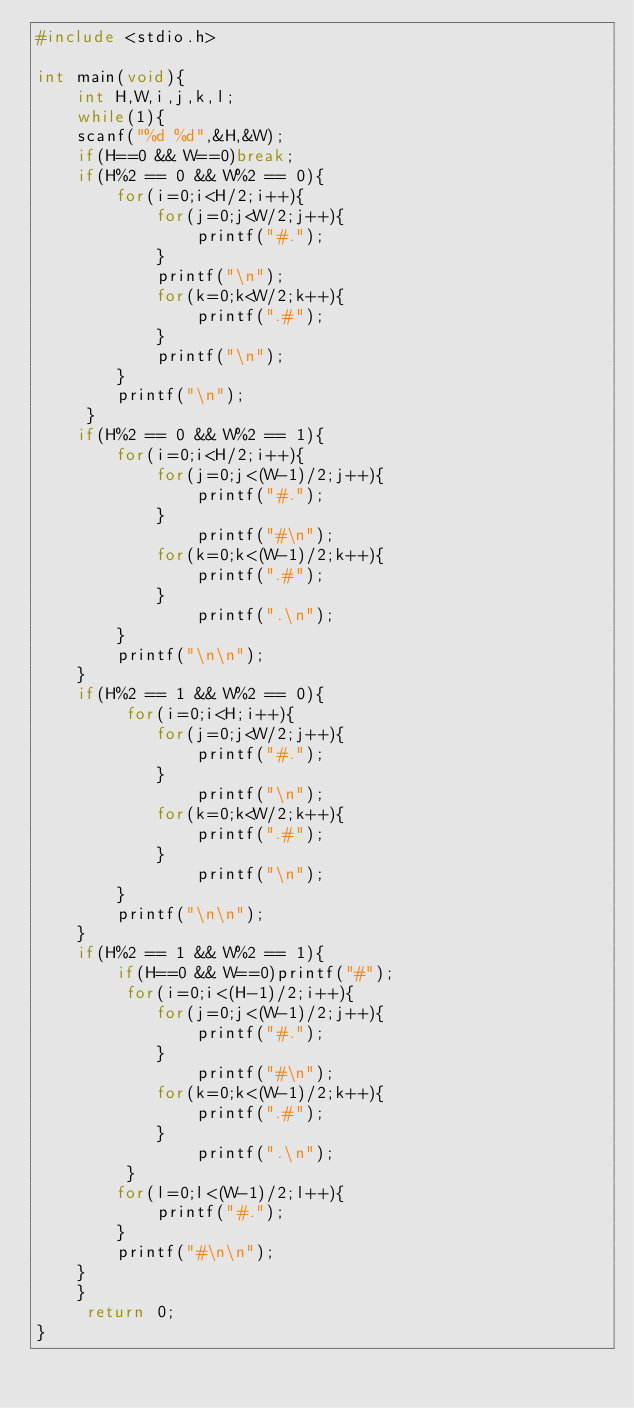Convert code to text. <code><loc_0><loc_0><loc_500><loc_500><_C_>#include <stdio.h>

int main(void){
    int H,W,i,j,k,l;
    while(1){
    scanf("%d %d",&H,&W);
    if(H==0 && W==0)break;
    if(H%2 == 0 && W%2 == 0){
        for(i=0;i<H/2;i++){
            for(j=0;j<W/2;j++){
                printf("#.");              
            }
            printf("\n");
            for(k=0;k<W/2;k++){
                printf(".#");
            }
            printf("\n");
        }
        printf("\n");
     }
    if(H%2 == 0 && W%2 == 1){
        for(i=0;i<H/2;i++){
            for(j=0;j<(W-1)/2;j++){
                printf("#.");
            }
                printf("#\n");
            for(k=0;k<(W-1)/2;k++){
                printf(".#");
            }
                printf(".\n");
        }
        printf("\n\n");
    }
    if(H%2 == 1 && W%2 == 0){
         for(i=0;i<H;i++){
            for(j=0;j<W/2;j++){
                printf("#.");
            }
                printf("\n");
            for(k=0;k<W/2;k++){
                printf(".#");
            }
                printf("\n");
        }
        printf("\n\n");
    }
    if(H%2 == 1 && W%2 == 1){
        if(H==0 && W==0)printf("#");
         for(i=0;i<(H-1)/2;i++){
            for(j=0;j<(W-1)/2;j++){
                printf("#.");
            }
                printf("#\n");
            for(k=0;k<(W-1)/2;k++){
                printf(".#");
            }
                printf(".\n");
         }
        for(l=0;l<(W-1)/2;l++){
            printf("#.");
        }
        printf("#\n\n");
    }
    }
     return 0;
}</code> 